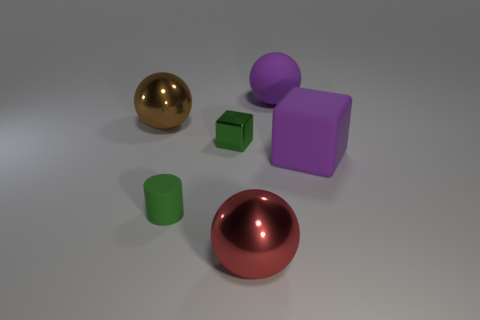Subtract all large red shiny balls. How many balls are left? 2 Add 1 green matte objects. How many objects exist? 7 Subtract all blocks. How many objects are left? 4 Subtract 1 balls. How many balls are left? 2 Subtract all big green shiny spheres. Subtract all large purple balls. How many objects are left? 5 Add 5 tiny shiny blocks. How many tiny shiny blocks are left? 6 Add 1 big yellow shiny blocks. How many big yellow shiny blocks exist? 1 Subtract 0 green spheres. How many objects are left? 6 Subtract all green spheres. Subtract all gray blocks. How many spheres are left? 3 